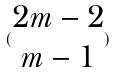Convert formula to latex. <formula><loc_0><loc_0><loc_500><loc_500>( \begin{matrix} 2 m - 2 \\ m - 1 \end{matrix} )</formula> 